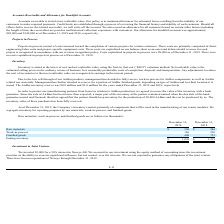According to Neonode's financial document, What kind of method is used to measure the inventory? the first-in, first-out (“FIFO”) valuation method. The document states: "the lower of cost and net realizable value, using the first-in, first-out (“FIFO”) valuation method. Net realizable value is the..." Also, What is the net realizable value? the estimated selling prices in the ordinary course of business, less reasonably predictable costs of completion, disposal, and transportation. The document states: "“FIFO”) valuation method. Net realizable value is the estimated selling prices in the ordinary course of business, less reasonably predictable costs o..." Also, What did the company do to protect its manufacturing partners from losses concerning AirBar production? agreed to secure the value of the inventory with a bank guarantee. The document states: "from losses in relation to AirBar production, we agreed to secure the value of the inventory with a bank guarantee. Since the sale of AirBars has been..." Also, can you calculate: What is the percentage change in the value of raw materials from 2018 to 2019? To answer this question, I need to perform calculations using the financial data. The calculation is: ($396-$246)/$246 , which equals 60.98 (percentage). This is based on the information: "Raw materials $ 396 $ 246 Raw materials $ 396 $ 246..." The key data points involved are: 246, 396. Also, can you calculate: What is the proportion of work-in-process and finished goods over ending inventory in 2018? To answer this question, I need to perform calculations using the financial data. The calculation is: (220+753)/$1,219 , which equals 0.8. This is based on the information: "Work-in-process 186 220 Ending inventory $ 1,030 $ 1,219 Finished goods 448 753..." The key data points involved are: 1,219, 220, 753. Also, can you calculate: What is the difference in ending inventory between 2018 and 2019? Based on the calculation: $1,219 - $1,030 , the result is 189 (in thousands). This is based on the information: "Ending inventory $ 1,030 $ 1,219 Ending inventory $ 1,030 $ 1,219..." The key data points involved are: 1,030, 1,219. 